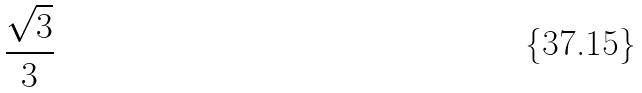Convert formula to latex. <formula><loc_0><loc_0><loc_500><loc_500>\frac { \sqrt { 3 } } { 3 }</formula> 